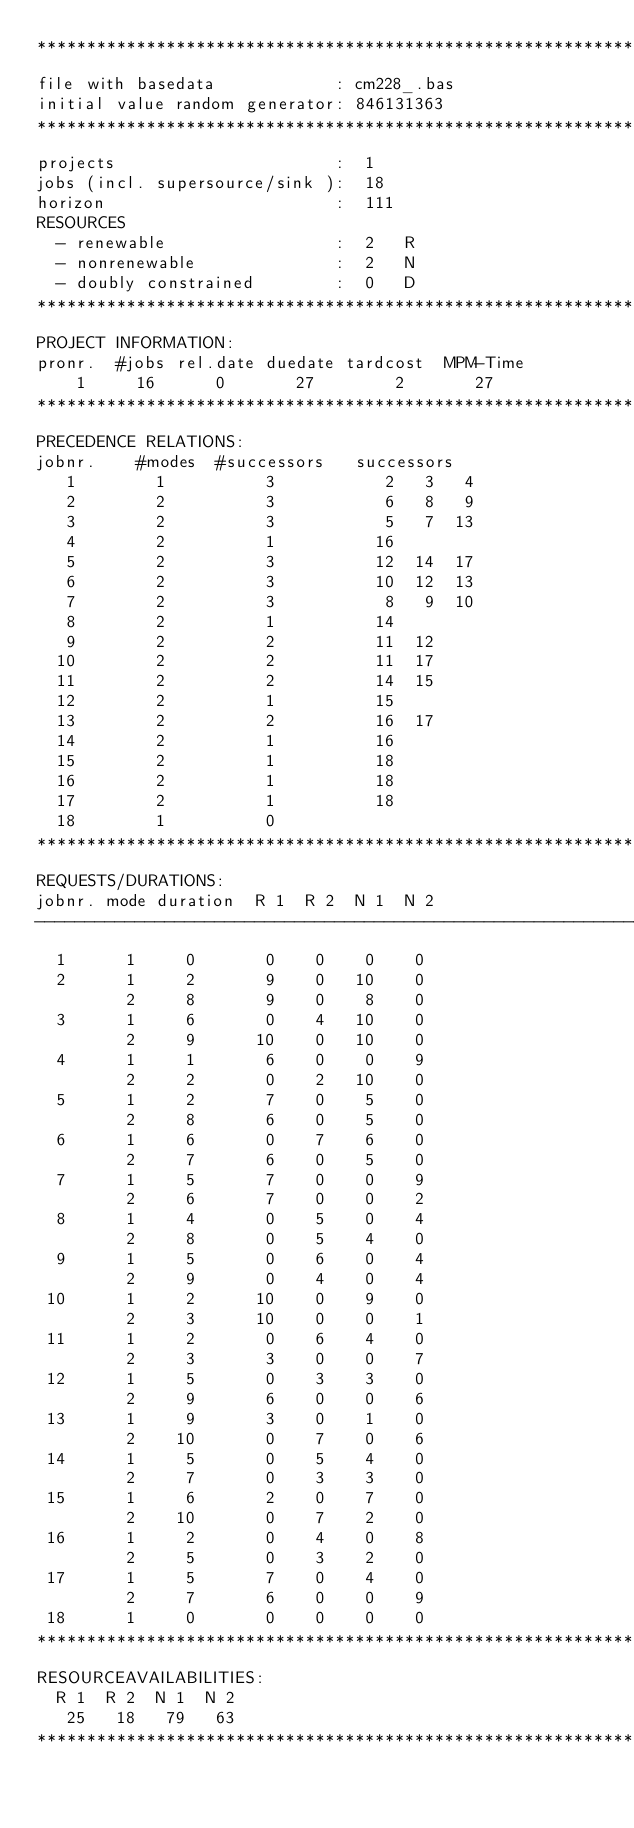Convert code to text. <code><loc_0><loc_0><loc_500><loc_500><_ObjectiveC_>************************************************************************
file with basedata            : cm228_.bas
initial value random generator: 846131363
************************************************************************
projects                      :  1
jobs (incl. supersource/sink ):  18
horizon                       :  111
RESOURCES
  - renewable                 :  2   R
  - nonrenewable              :  2   N
  - doubly constrained        :  0   D
************************************************************************
PROJECT INFORMATION:
pronr.  #jobs rel.date duedate tardcost  MPM-Time
    1     16      0       27        2       27
************************************************************************
PRECEDENCE RELATIONS:
jobnr.    #modes  #successors   successors
   1        1          3           2   3   4
   2        2          3           6   8   9
   3        2          3           5   7  13
   4        2          1          16
   5        2          3          12  14  17
   6        2          3          10  12  13
   7        2          3           8   9  10
   8        2          1          14
   9        2          2          11  12
  10        2          2          11  17
  11        2          2          14  15
  12        2          1          15
  13        2          2          16  17
  14        2          1          16
  15        2          1          18
  16        2          1          18
  17        2          1          18
  18        1          0        
************************************************************************
REQUESTS/DURATIONS:
jobnr. mode duration  R 1  R 2  N 1  N 2
------------------------------------------------------------------------
  1      1     0       0    0    0    0
  2      1     2       9    0   10    0
         2     8       9    0    8    0
  3      1     6       0    4   10    0
         2     9      10    0   10    0
  4      1     1       6    0    0    9
         2     2       0    2   10    0
  5      1     2       7    0    5    0
         2     8       6    0    5    0
  6      1     6       0    7    6    0
         2     7       6    0    5    0
  7      1     5       7    0    0    9
         2     6       7    0    0    2
  8      1     4       0    5    0    4
         2     8       0    5    4    0
  9      1     5       0    6    0    4
         2     9       0    4    0    4
 10      1     2      10    0    9    0
         2     3      10    0    0    1
 11      1     2       0    6    4    0
         2     3       3    0    0    7
 12      1     5       0    3    3    0
         2     9       6    0    0    6
 13      1     9       3    0    1    0
         2    10       0    7    0    6
 14      1     5       0    5    4    0
         2     7       0    3    3    0
 15      1     6       2    0    7    0
         2    10       0    7    2    0
 16      1     2       0    4    0    8
         2     5       0    3    2    0
 17      1     5       7    0    4    0
         2     7       6    0    0    9
 18      1     0       0    0    0    0
************************************************************************
RESOURCEAVAILABILITIES:
  R 1  R 2  N 1  N 2
   25   18   79   63
************************************************************************
</code> 